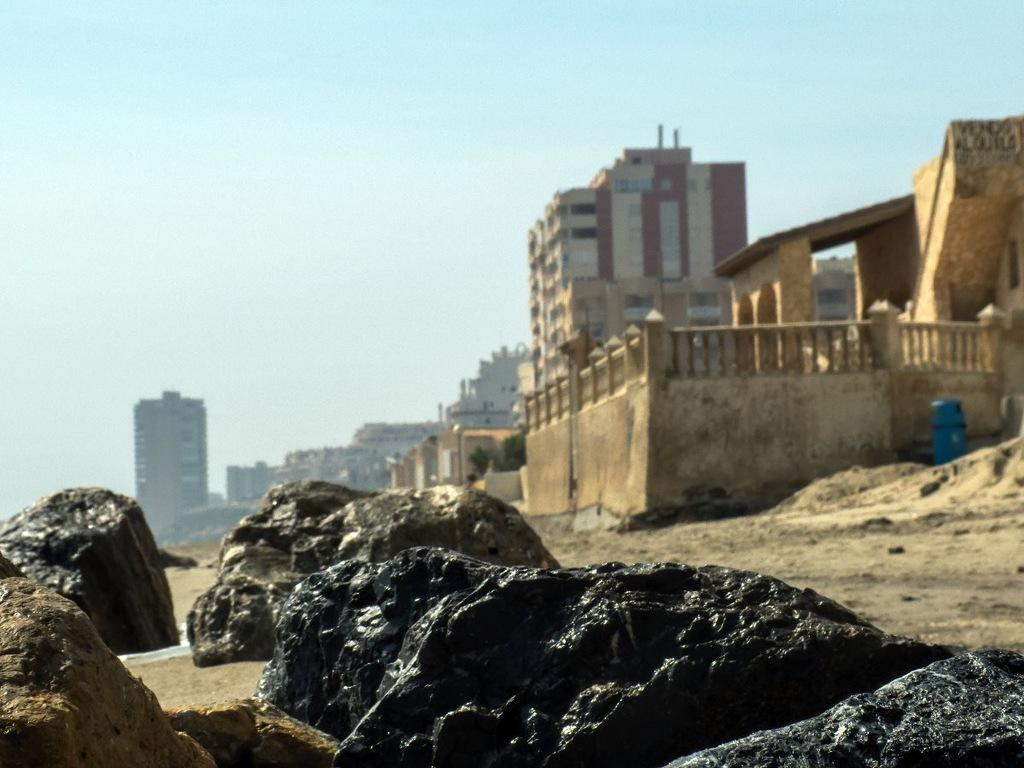What is located in the foreground of the image? There are rocks in the foreground of the image. What can be seen in the background of the image? There is sand, buildings, a fence, and the sky visible in the background of the image. What time of day was the image taken? The image was taken during the day. Where is the playground located in the image? There is no playground present in the image. What trick can be performed with the rocks in the foreground? There is no trick mentioned or implied in the image; it simply shows rocks in the foreground. 